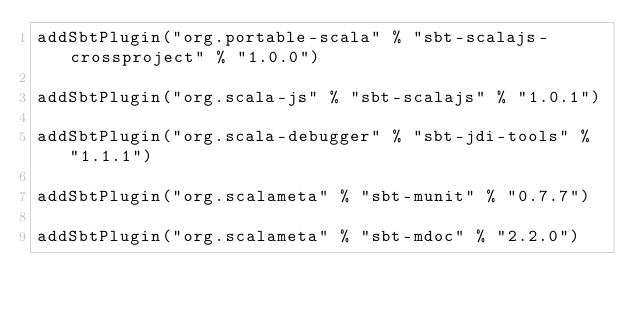<code> <loc_0><loc_0><loc_500><loc_500><_Scala_>addSbtPlugin("org.portable-scala" % "sbt-scalajs-crossproject" % "1.0.0")

addSbtPlugin("org.scala-js" % "sbt-scalajs" % "1.0.1")

addSbtPlugin("org.scala-debugger" % "sbt-jdi-tools" % "1.1.1")

addSbtPlugin("org.scalameta" % "sbt-munit" % "0.7.7")

addSbtPlugin("org.scalameta" % "sbt-mdoc" % "2.2.0")
</code> 